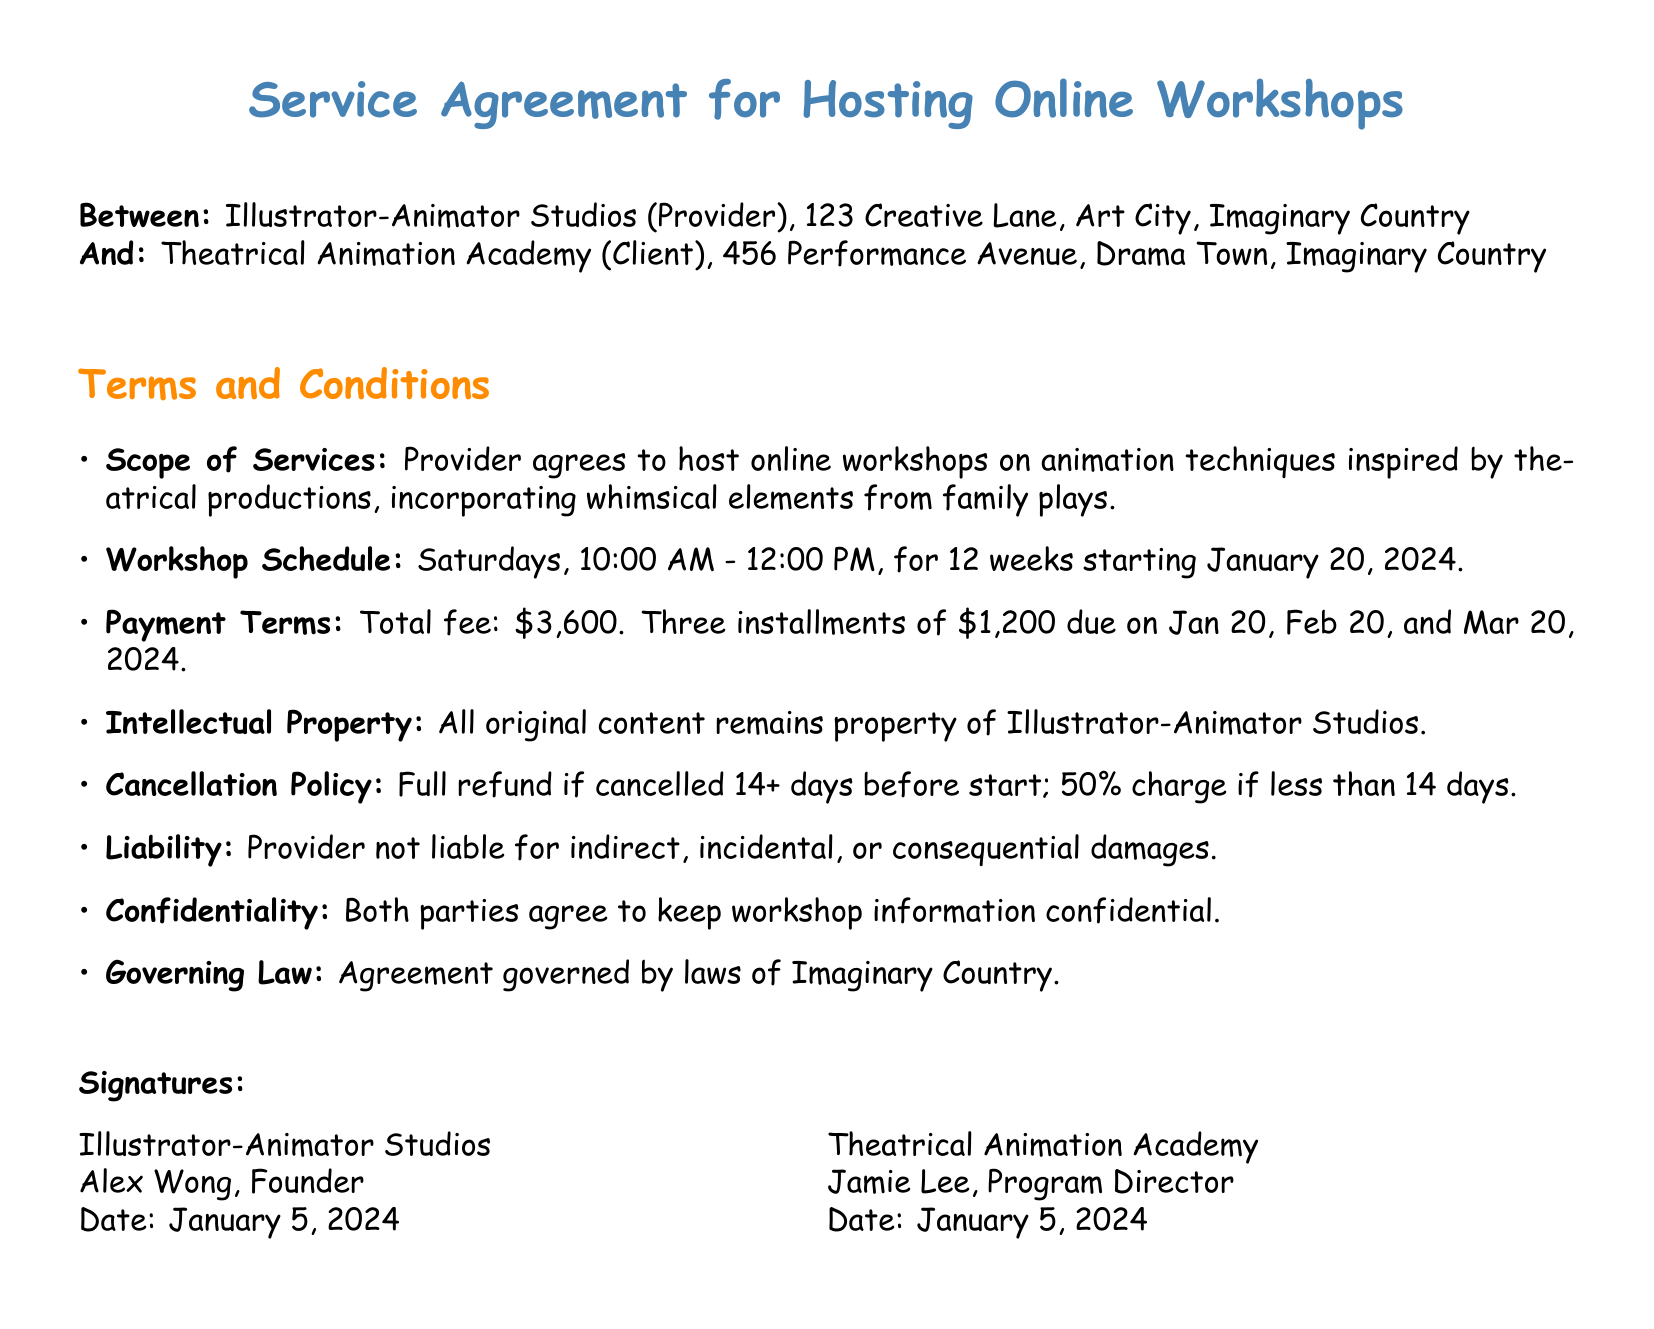What is the name of the Provider? The Provider is specified as "Illustrator-Animator Studios" in the document.
Answer: Illustrator-Animator Studios What is the total fee for the workshops? The total fee is clearly stated as $3,600 in the payment terms section of the document.
Answer: $3,600 On which day of the week are the workshops scheduled? The workshop schedule specifies that the workshops will take place on Saturdays.
Answer: Saturdays How many weeks will the workshops run? The duration of the workshops is indicated as 12 weeks in the schedule section.
Answer: 12 weeks What is the cancellation charge if cancelled less than 14 days before the start? The cancellation policy mentions a 50% charge if cancelled less than 14 days before the start.
Answer: 50% Who is the Program Director at Theatrical Animation Academy? The document names Jamie Lee as the Program Director in the signatures section.
Answer: Jamie Lee Which country's laws govern this agreement? The governing law for the agreement is stated as the laws of Imaginary Country.
Answer: Imaginary Country What is the first payment due date? The first payment is due on January 20, 2024, as per the payment terms section.
Answer: January 20, 2024 What type of content ownership is mentioned in the contract? The contract specifies that all original content remains the property of Illustrator-Animator Studios.
Answer: Illustrator-Animator Studios 